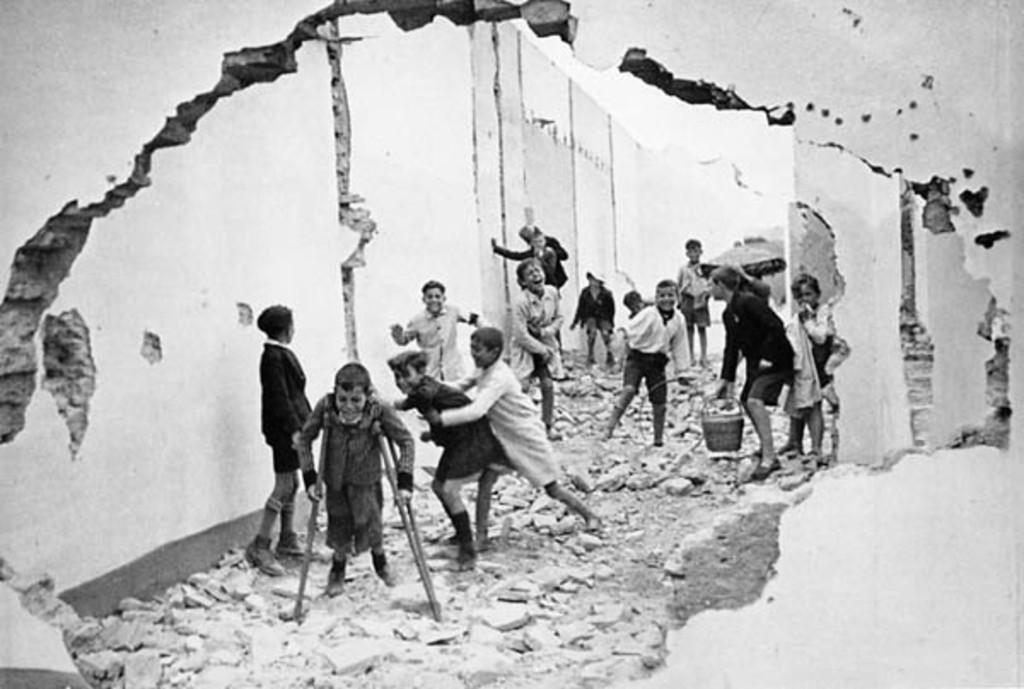Describe this image in one or two sentences. In this image I can see number of children are standing. I can also see this image is black and white in colour. 